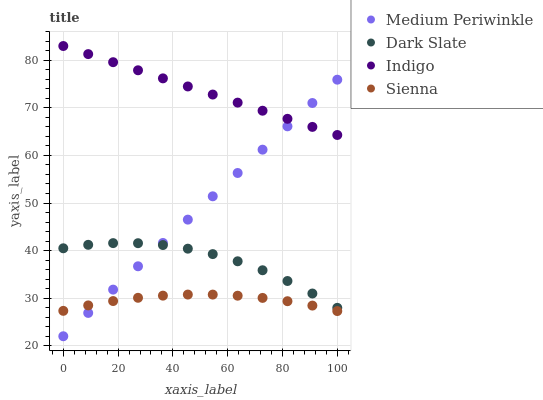Does Sienna have the minimum area under the curve?
Answer yes or no. Yes. Does Indigo have the maximum area under the curve?
Answer yes or no. Yes. Does Dark Slate have the minimum area under the curve?
Answer yes or no. No. Does Dark Slate have the maximum area under the curve?
Answer yes or no. No. Is Indigo the smoothest?
Answer yes or no. Yes. Is Dark Slate the roughest?
Answer yes or no. Yes. Is Medium Periwinkle the smoothest?
Answer yes or no. No. Is Medium Periwinkle the roughest?
Answer yes or no. No. Does Medium Periwinkle have the lowest value?
Answer yes or no. Yes. Does Dark Slate have the lowest value?
Answer yes or no. No. Does Indigo have the highest value?
Answer yes or no. Yes. Does Dark Slate have the highest value?
Answer yes or no. No. Is Dark Slate less than Indigo?
Answer yes or no. Yes. Is Indigo greater than Sienna?
Answer yes or no. Yes. Does Dark Slate intersect Medium Periwinkle?
Answer yes or no. Yes. Is Dark Slate less than Medium Periwinkle?
Answer yes or no. No. Is Dark Slate greater than Medium Periwinkle?
Answer yes or no. No. Does Dark Slate intersect Indigo?
Answer yes or no. No. 